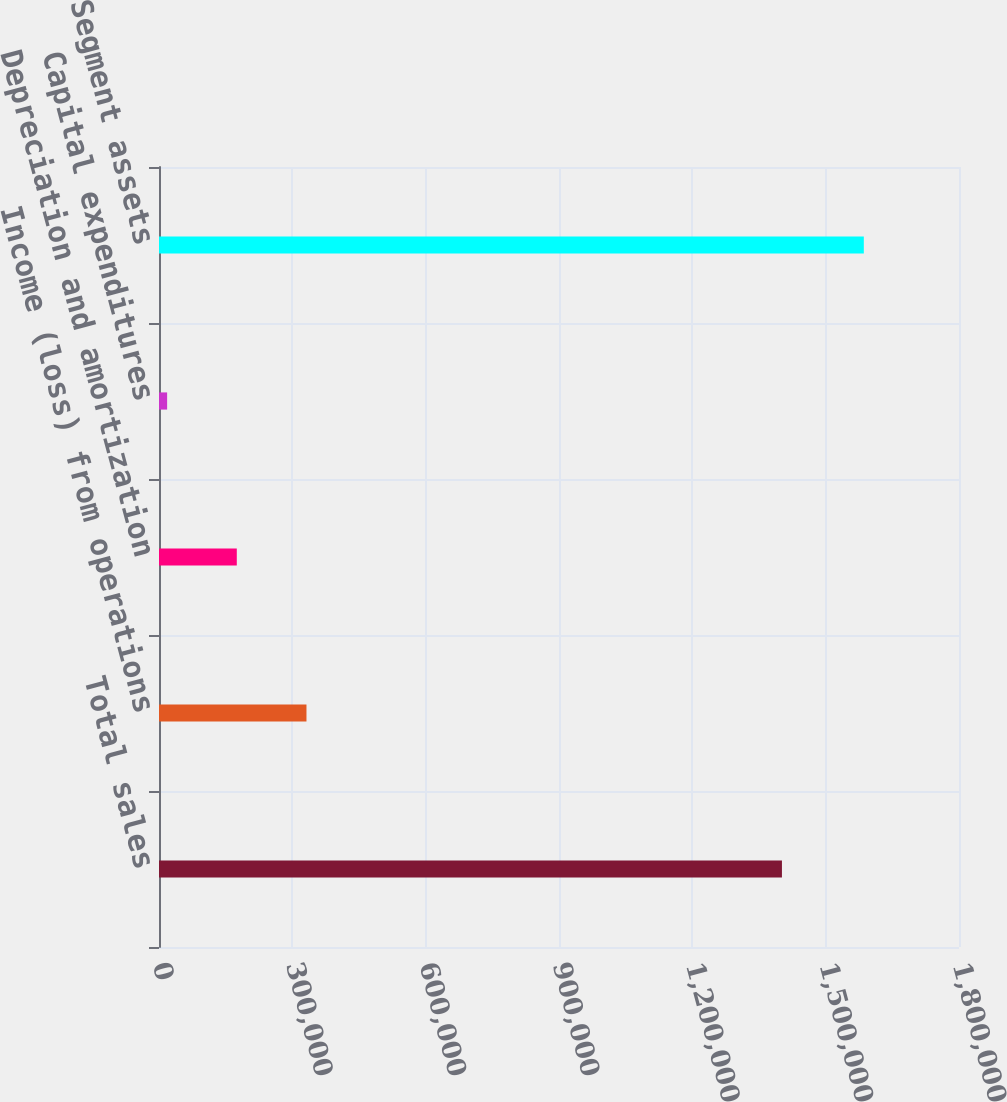Convert chart. <chart><loc_0><loc_0><loc_500><loc_500><bar_chart><fcel>Total sales<fcel>Income (loss) from operations<fcel>Depreciation and amortization<fcel>Capital expenditures<fcel>Segment assets<nl><fcel>1.40162e+06<fcel>331797<fcel>175043<fcel>18288<fcel>1.58584e+06<nl></chart> 